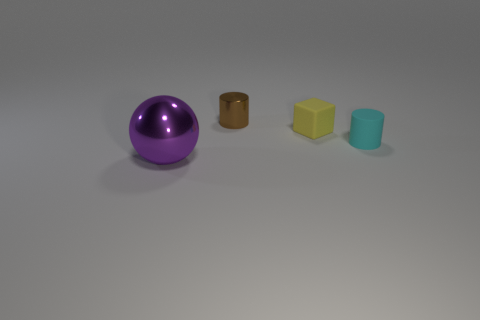Is there a big brown rubber ball?
Provide a succinct answer. No. Are there any other things that are the same color as the big metal object?
Make the answer very short. No. The other object that is made of the same material as the small cyan thing is what shape?
Give a very brief answer. Cube. There is a cylinder to the left of the tiny cylinder in front of the small cylinder that is behind the small cube; what color is it?
Provide a short and direct response. Brown. Are there the same number of tiny brown metallic cylinders that are in front of the small metal object and cyan objects?
Provide a succinct answer. No. Is there any other thing that is made of the same material as the brown object?
Make the answer very short. Yes. There is a metal sphere; is its color the same as the small rubber object in front of the tiny yellow cube?
Your answer should be compact. No. Are there any small matte cylinders to the right of the small cylinder that is right of the shiny thing behind the purple shiny sphere?
Provide a succinct answer. No. Is the number of small brown metallic cylinders left of the tiny metal cylinder less than the number of gray matte objects?
Provide a succinct answer. No. What number of other things are there of the same shape as the brown object?
Offer a terse response. 1. 